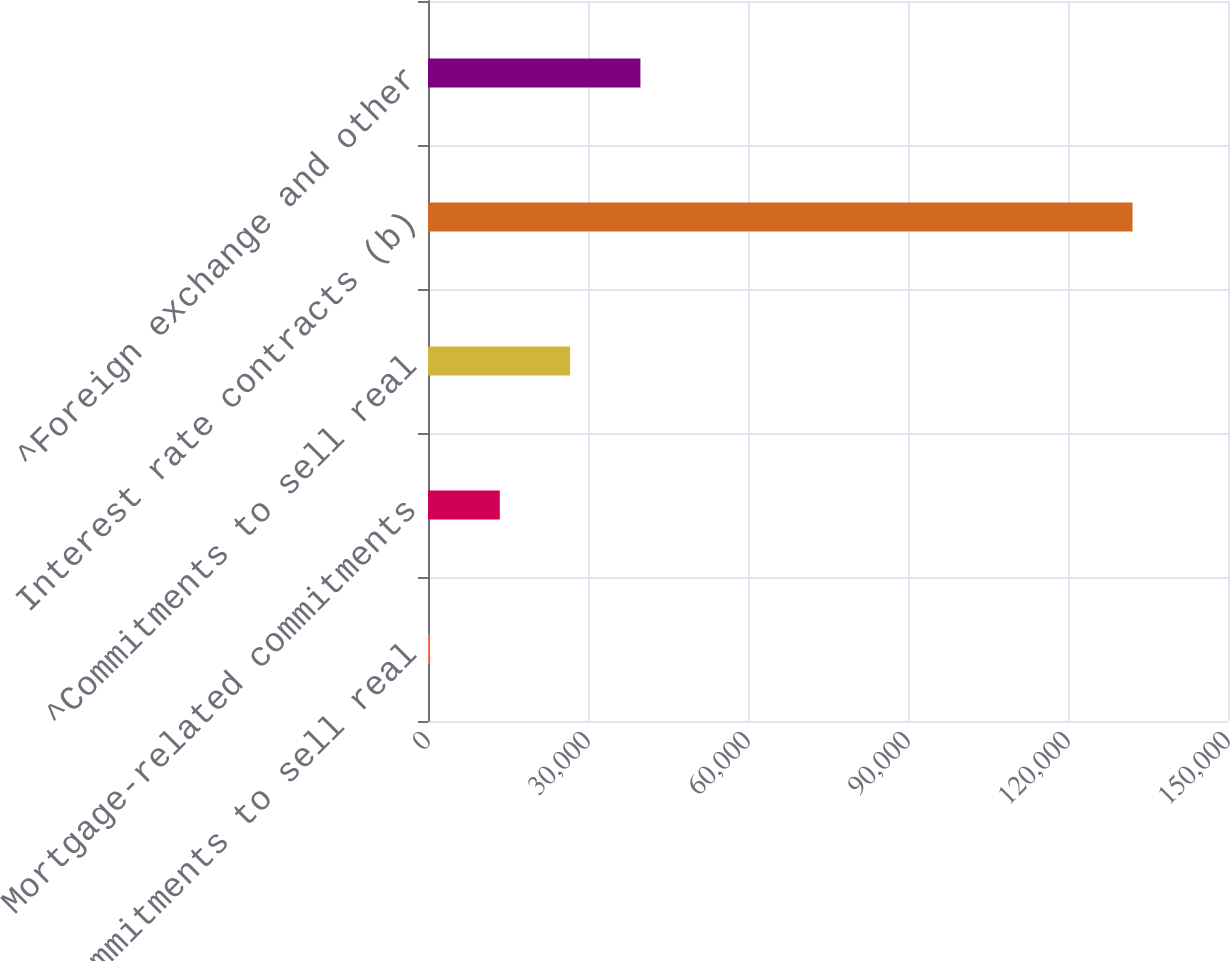<chart> <loc_0><loc_0><loc_500><loc_500><bar_chart><fcel>Commitments to sell real<fcel>Mortgage-related commitments<fcel>^Commitments to sell real<fcel>Interest rate contracts (b)<fcel>^Foreign exchange and other<nl><fcel>283<fcel>13465.1<fcel>26647.2<fcel>132104<fcel>39829.3<nl></chart> 